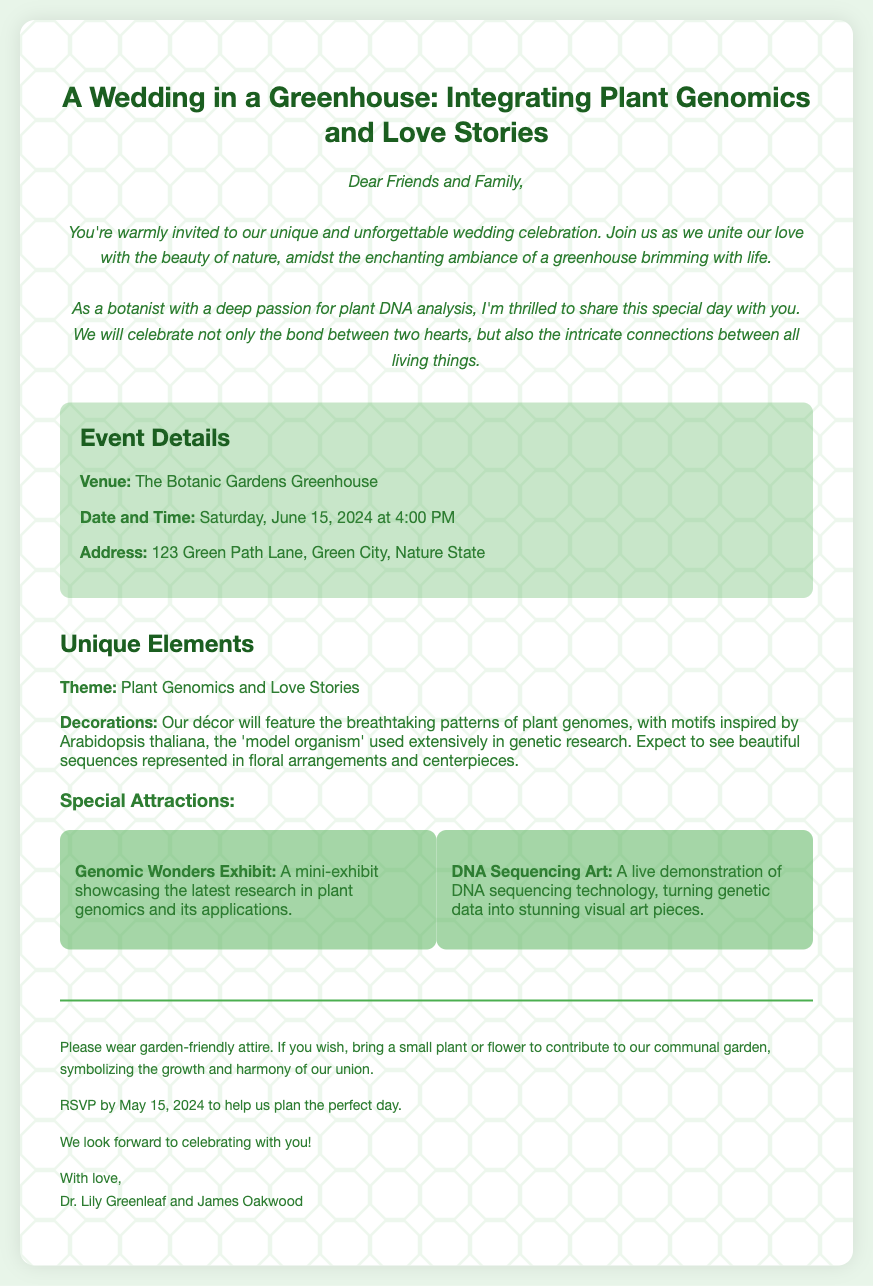What is the wedding date? The wedding date is explicitly mentioned in the document under "Date and Time."
Answer: Saturday, June 15, 2024 What is the venue of the wedding? The venue is listed in the "Event Details" section.
Answer: The Botanic Gardens Greenhouse Who are the couple getting married? The names of the couple are found at the end of the invitation.
Answer: Dr. Lily Greenleaf and James Oakwood What theme is integrated into the wedding? The theme is discussed in the "Unique Elements" section.
Answer: Plant Genomics and Love Stories What should guests contribute to the communal garden? The invitation mentions a specific item to bring for the communal garden.
Answer: A small plant or flower What is the RSVP deadline? The RSVP date is provided in the notes section of the invitation.
Answer: May 15, 2024 What type of exhibit will be at the wedding? The festival features a specific type of exhibit mentioned in the attractions section.
Answer: Genomic Wonders Exhibit What should guests wear to the wedding? The dress code is mentioned in the notes section of the invitation.
Answer: Garden-friendly attire 